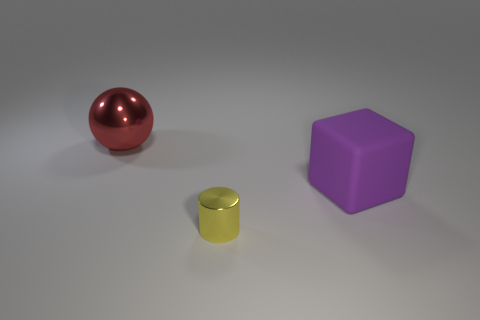Are there any other things that are the same size as the cylinder? Based on the image, the cylinder appears to be smaller than both the sphere and the cube. The cylinder's exact dimensions relative to the other objects cannot be determined with absolute precision from this perspective, but it seems to be of a unique size among the objects present. 